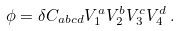<formula> <loc_0><loc_0><loc_500><loc_500>\phi = \delta C _ { a b c d } V ^ { a } _ { 1 } V ^ { b } _ { 2 } V ^ { c } _ { 3 } V ^ { d } _ { 4 } \, .</formula> 